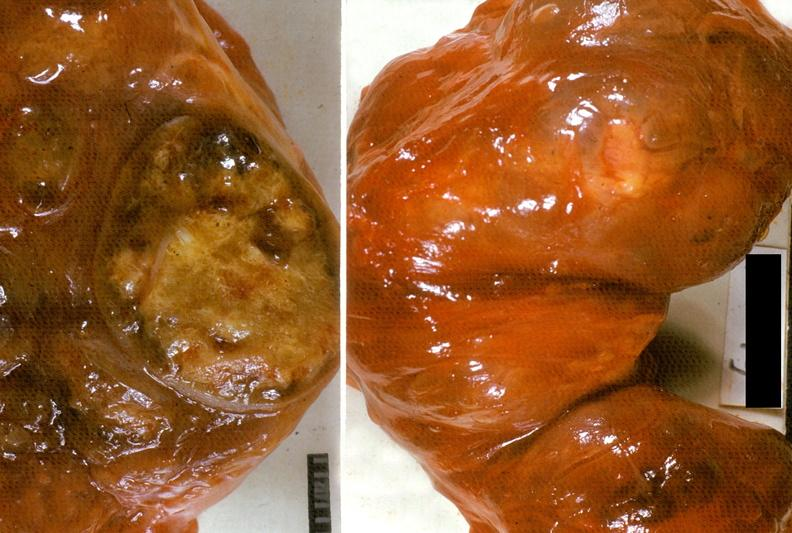what does this image show?
Answer the question using a single word or phrase. Thyroid 